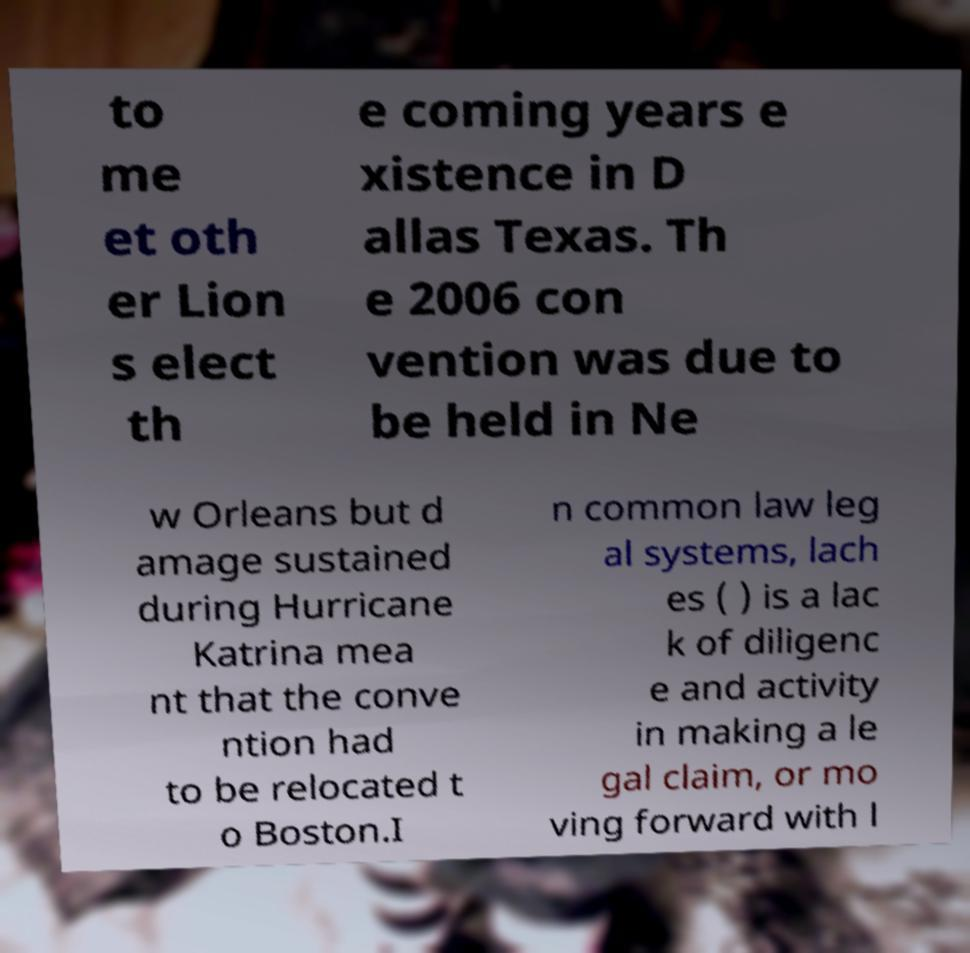Please identify and transcribe the text found in this image. to me et oth er Lion s elect th e coming years e xistence in D allas Texas. Th e 2006 con vention was due to be held in Ne w Orleans but d amage sustained during Hurricane Katrina mea nt that the conve ntion had to be relocated t o Boston.I n common law leg al systems, lach es ( ) is a lac k of diligenc e and activity in making a le gal claim, or mo ving forward with l 